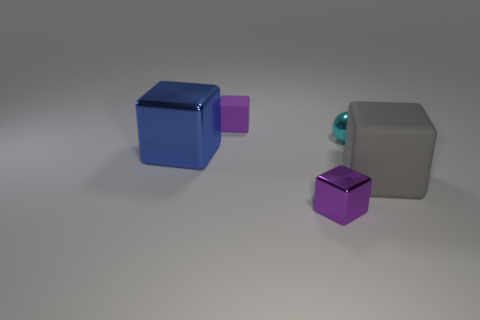Add 3 big blue shiny cylinders. How many objects exist? 8 Subtract all balls. How many objects are left? 4 Add 4 small matte cylinders. How many small matte cylinders exist? 4 Subtract 0 blue spheres. How many objects are left? 5 Subtract all blue matte balls. Subtract all cyan shiny things. How many objects are left? 4 Add 4 rubber objects. How many rubber objects are left? 6 